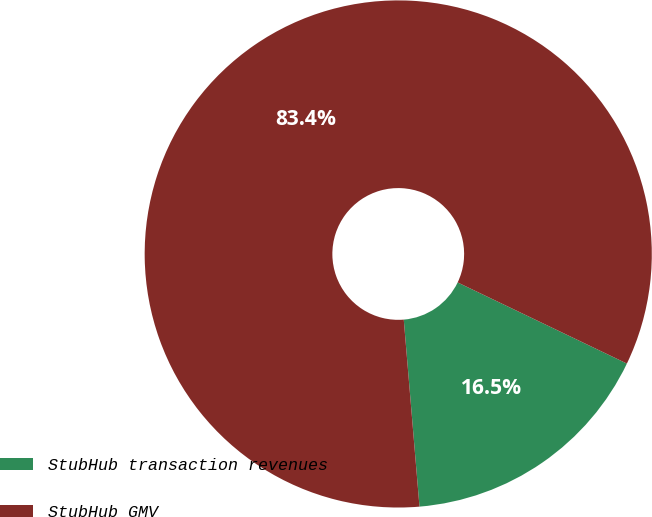Convert chart to OTSL. <chart><loc_0><loc_0><loc_500><loc_500><pie_chart><fcel>StubHub transaction revenues<fcel>StubHub GMV<nl><fcel>16.55%<fcel>83.45%<nl></chart> 